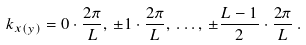Convert formula to latex. <formula><loc_0><loc_0><loc_500><loc_500>k _ { x ( y ) } = 0 \cdot \frac { 2 \pi } { L } , \, \pm 1 \cdot \frac { 2 \pi } { L } , \, \dots , \, \pm \frac { L - 1 } { 2 } \cdot \frac { 2 \pi } { L } \, .</formula> 